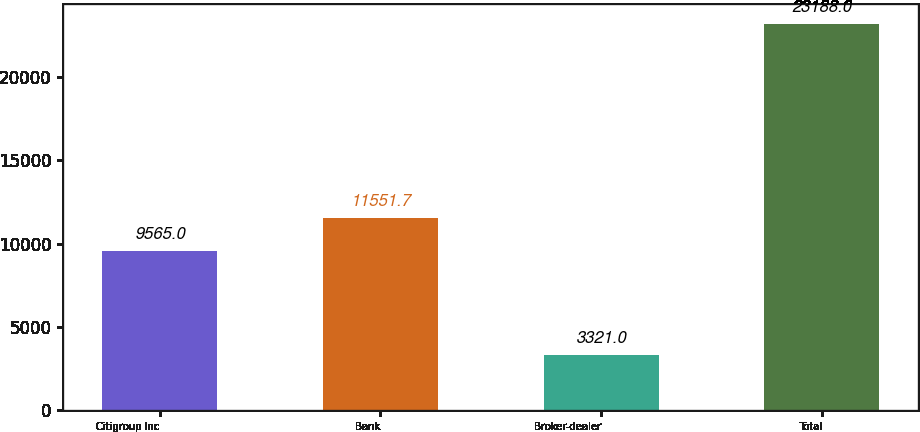<chart> <loc_0><loc_0><loc_500><loc_500><bar_chart><fcel>Citigroup Inc<fcel>Bank<fcel>Broker-dealer<fcel>Total<nl><fcel>9565<fcel>11551.7<fcel>3321<fcel>23188<nl></chart> 